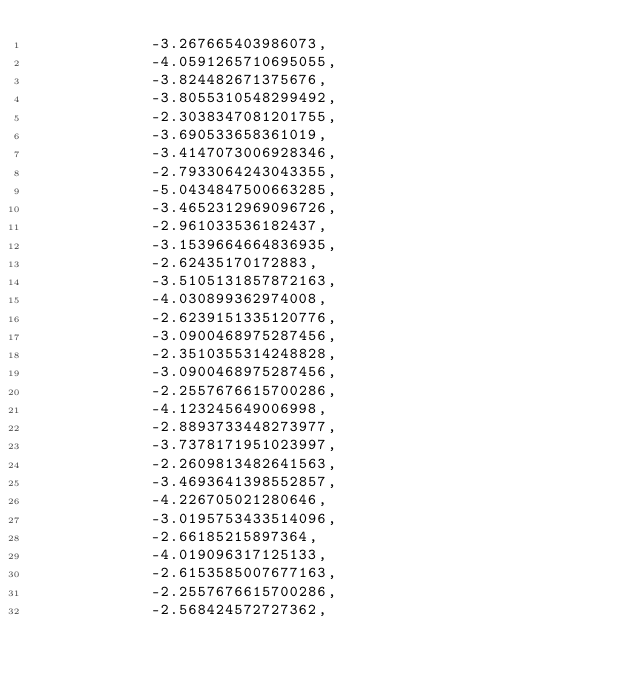Convert code to text. <code><loc_0><loc_0><loc_500><loc_500><_Python_>            -3.267665403986073,
            -4.0591265710695055,
            -3.824482671375676,
            -3.8055310548299492,
            -2.3038347081201755,
            -3.690533658361019,
            -3.4147073006928346,
            -2.7933064243043355,
            -5.0434847500663285,
            -3.4652312969096726,
            -2.961033536182437,
            -3.1539664664836935,
            -2.62435170172883,
            -3.5105131857872163,
            -4.030899362974008,
            -2.6239151335120776,
            -3.0900468975287456,
            -2.3510355314248828,
            -3.0900468975287456,
            -2.2557676615700286,
            -4.123245649006998,
            -2.8893733448273977,
            -3.7378171951023997,
            -2.2609813482641563,
            -3.4693641398552857,
            -4.226705021280646,
            -3.0195753433514096,
            -2.66185215897364,
            -4.019096317125133,
            -2.6153585007677163,
            -2.2557676615700286,
            -2.568424572727362,</code> 